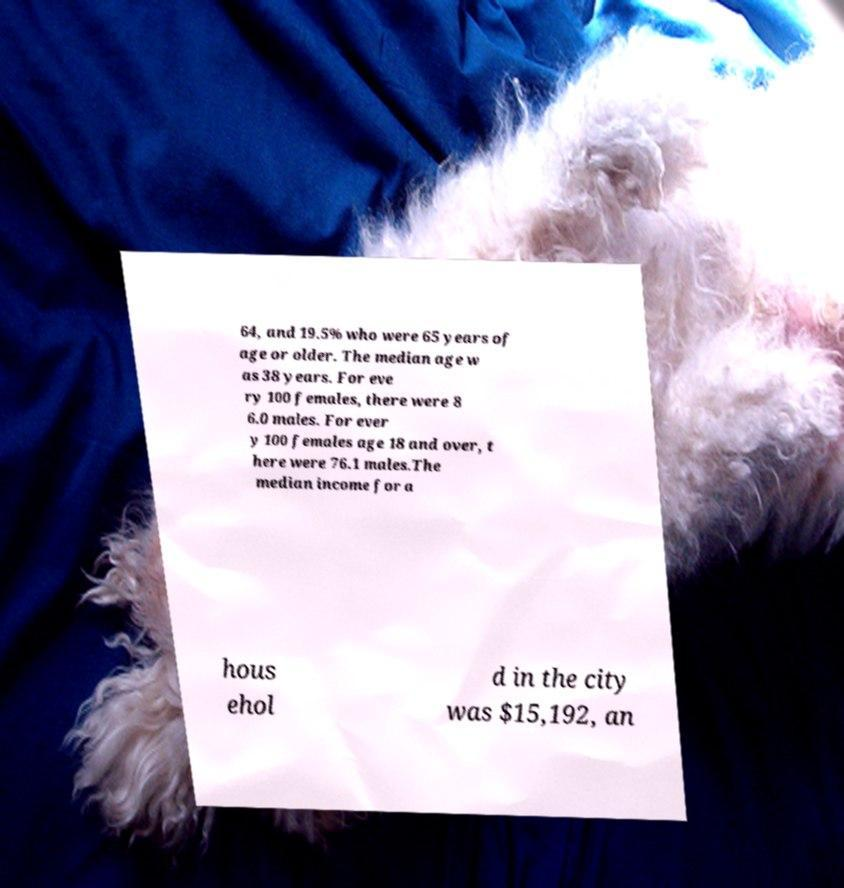For documentation purposes, I need the text within this image transcribed. Could you provide that? 64, and 19.5% who were 65 years of age or older. The median age w as 38 years. For eve ry 100 females, there were 8 6.0 males. For ever y 100 females age 18 and over, t here were 76.1 males.The median income for a hous ehol d in the city was $15,192, an 